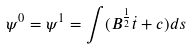<formula> <loc_0><loc_0><loc_500><loc_500>\psi ^ { 0 } = \psi ^ { 1 } = \int ( B ^ { \frac { 1 } { 2 } } \dot { t } + c ) d s</formula> 